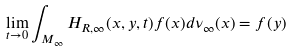Convert formula to latex. <formula><loc_0><loc_0><loc_500><loc_500>\lim _ { t \rightarrow 0 } \int _ { M _ { \infty } } H _ { R , \infty } ( x , y , t ) f ( x ) d \nu _ { \infty } ( x ) = f ( y )</formula> 